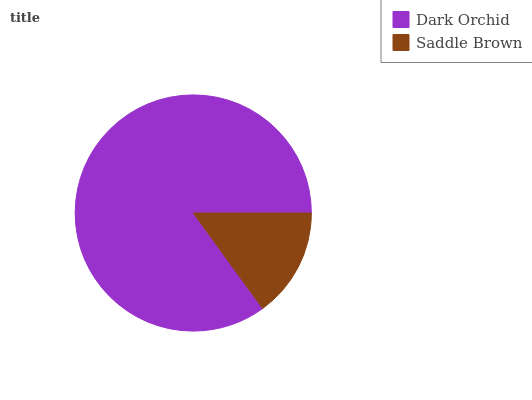Is Saddle Brown the minimum?
Answer yes or no. Yes. Is Dark Orchid the maximum?
Answer yes or no. Yes. Is Saddle Brown the maximum?
Answer yes or no. No. Is Dark Orchid greater than Saddle Brown?
Answer yes or no. Yes. Is Saddle Brown less than Dark Orchid?
Answer yes or no. Yes. Is Saddle Brown greater than Dark Orchid?
Answer yes or no. No. Is Dark Orchid less than Saddle Brown?
Answer yes or no. No. Is Dark Orchid the high median?
Answer yes or no. Yes. Is Saddle Brown the low median?
Answer yes or no. Yes. Is Saddle Brown the high median?
Answer yes or no. No. Is Dark Orchid the low median?
Answer yes or no. No. 